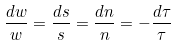<formula> <loc_0><loc_0><loc_500><loc_500>\frac { d w } { w } = \frac { d s } { s } = \frac { d n } { n } = - \frac { d \tau } { \tau }</formula> 